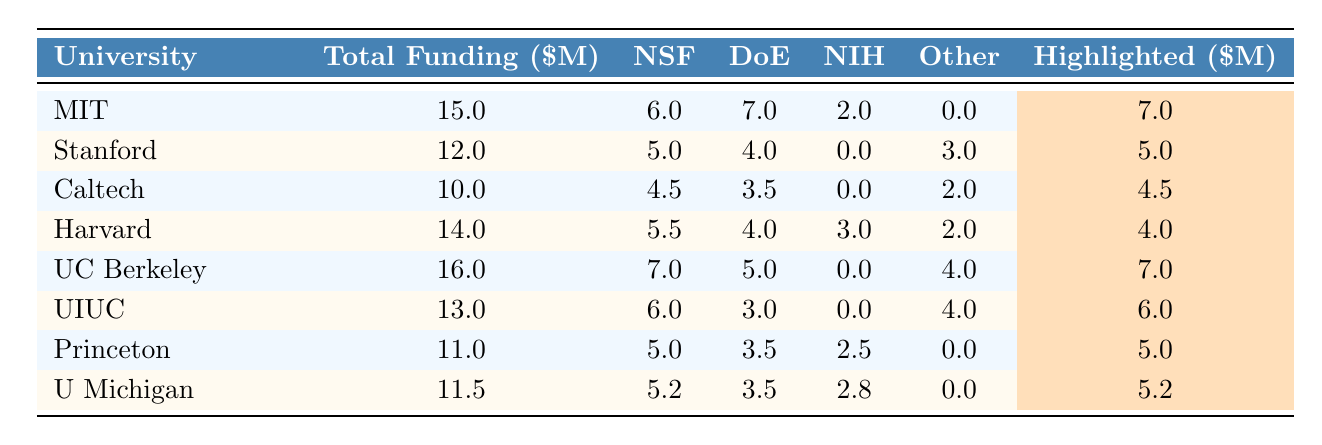What is the total funding allocated to the University of California, Berkeley? The row for the University of California, Berkeley shows a total funding value of 16.0 million dollars.
Answer: 16.0 million dollars Which university received the least funding from the Department of Energy (DoE)? By examining the Department of Energy funding column, the minimum value is 3.0 million dollars, which goes to Princeton University and University of Illinois at Urbana-Champaign. Both have the same amount for DoE funding.
Answer: Princeton University and University of Illinois at Urbana-Champaign What is the total funding for Harvard University from all sources? The total funding amount listed for Harvard University in the table is 14.0 million dollars.
Answer: 14.0 million dollars How much funding did Stanford University receive from NSF? According to the table, Stanford University received 5.0 million dollars from the National Science Foundation (NSF).
Answer: 5.0 million dollars What is the average highlighted funding among all universities listed? The highlighted funding amounts are 7.0, 5.0, 4.5, 4.0, 7.0, 6.0, 5.0, and 5.2 million dollars. The sum is 7.0 + 5.0 + 4.5 + 4.0 + 7.0 + 6.0 + 5.0 + 5.2 = 44.7 million dollars. There are 8 universities, so the average is 44.7 / 8 = 5.5875 million dollars.
Answer: 5.59 million dollars Which university received the highest funding from private donations? Looking at the "Other" funding column, the maximum value is 4.0 million dollars, and the University of California, Berkeley is noted to have this allocation.
Answer: University of California, Berkeley Is it true that University of Michigan received more total funding than Princeton University? The total funding for University of Michigan is 11.5 million dollars, while for Princeton University it is 11.0 million dollars. Since 11.5 million is greater than 11.0 million, the statement is true.
Answer: Yes What is the difference in the total funding between MIT and Caltech? Total funding for MIT is 15.0 million dollars and for Caltech it is 10.0 million dollars. The difference is calculated as 15.0 - 10.0 = 5.0 million dollars.
Answer: 5.0 million dollars How does the total funding of University of Illinois at Urbana-Champaign compare to Stanford University? University of Illinois at Urbana-Champaign has total funding of 13.0 million dollars, while Stanford University has 12.0 million dollars. Therefore, UIUC has more funding by 1.0 million dollars.
Answer: University of Illinois at Urbana-Champaign has more funding by 1.0 million dollars What percentage of total funding did California Institute of Technology receive from NSF? Total funding for Caltech is 10.0 million dollars, and NSF funding is 4.5 million dollars. The percentage is (4.5 / 10) * 100 = 45%.
Answer: 45% Which two universities have the same highlighted funding amount? By reviewing the highlighted values, both Stanford University and Princeton University have a highlighted amount of 5.0 million dollars.
Answer: Stanford University and Princeton University 